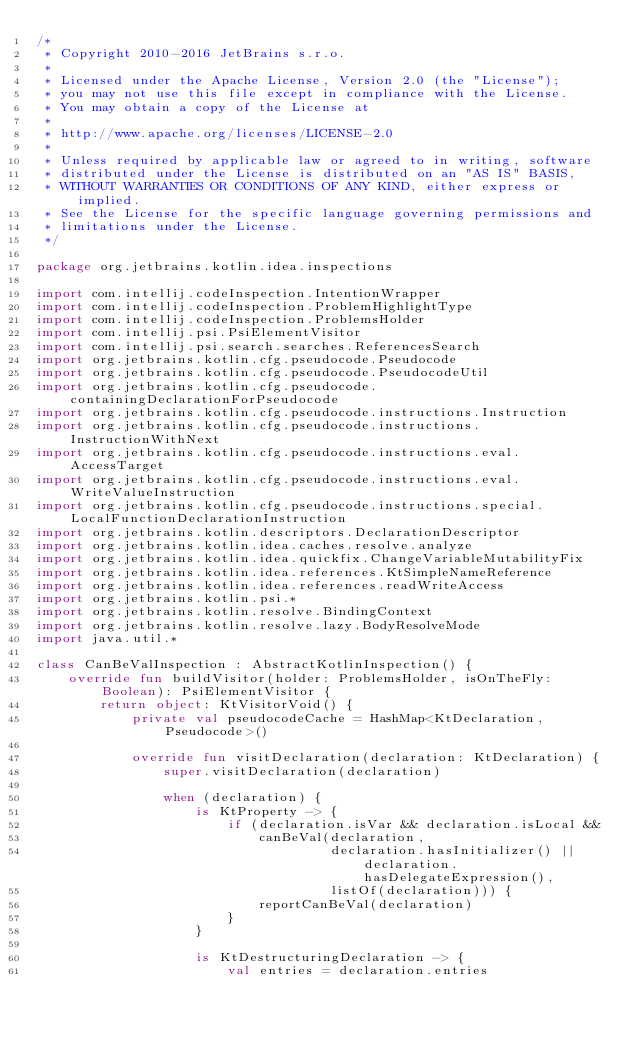Convert code to text. <code><loc_0><loc_0><loc_500><loc_500><_Kotlin_>/*
 * Copyright 2010-2016 JetBrains s.r.o.
 *
 * Licensed under the Apache License, Version 2.0 (the "License");
 * you may not use this file except in compliance with the License.
 * You may obtain a copy of the License at
 *
 * http://www.apache.org/licenses/LICENSE-2.0
 *
 * Unless required by applicable law or agreed to in writing, software
 * distributed under the License is distributed on an "AS IS" BASIS,
 * WITHOUT WARRANTIES OR CONDITIONS OF ANY KIND, either express or implied.
 * See the License for the specific language governing permissions and
 * limitations under the License.
 */

package org.jetbrains.kotlin.idea.inspections

import com.intellij.codeInspection.IntentionWrapper
import com.intellij.codeInspection.ProblemHighlightType
import com.intellij.codeInspection.ProblemsHolder
import com.intellij.psi.PsiElementVisitor
import com.intellij.psi.search.searches.ReferencesSearch
import org.jetbrains.kotlin.cfg.pseudocode.Pseudocode
import org.jetbrains.kotlin.cfg.pseudocode.PseudocodeUtil
import org.jetbrains.kotlin.cfg.pseudocode.containingDeclarationForPseudocode
import org.jetbrains.kotlin.cfg.pseudocode.instructions.Instruction
import org.jetbrains.kotlin.cfg.pseudocode.instructions.InstructionWithNext
import org.jetbrains.kotlin.cfg.pseudocode.instructions.eval.AccessTarget
import org.jetbrains.kotlin.cfg.pseudocode.instructions.eval.WriteValueInstruction
import org.jetbrains.kotlin.cfg.pseudocode.instructions.special.LocalFunctionDeclarationInstruction
import org.jetbrains.kotlin.descriptors.DeclarationDescriptor
import org.jetbrains.kotlin.idea.caches.resolve.analyze
import org.jetbrains.kotlin.idea.quickfix.ChangeVariableMutabilityFix
import org.jetbrains.kotlin.idea.references.KtSimpleNameReference
import org.jetbrains.kotlin.idea.references.readWriteAccess
import org.jetbrains.kotlin.psi.*
import org.jetbrains.kotlin.resolve.BindingContext
import org.jetbrains.kotlin.resolve.lazy.BodyResolveMode
import java.util.*

class CanBeValInspection : AbstractKotlinInspection() {
    override fun buildVisitor(holder: ProblemsHolder, isOnTheFly: Boolean): PsiElementVisitor {
        return object: KtVisitorVoid() {
            private val pseudocodeCache = HashMap<KtDeclaration, Pseudocode>()

            override fun visitDeclaration(declaration: KtDeclaration) {
                super.visitDeclaration(declaration)

                when (declaration) {
                    is KtProperty -> {
                        if (declaration.isVar && declaration.isLocal &&
                            canBeVal(declaration,
                                     declaration.hasInitializer() || declaration.hasDelegateExpression(),
                                     listOf(declaration))) {
                            reportCanBeVal(declaration)
                        }
                    }

                    is KtDestructuringDeclaration -> {
                        val entries = declaration.entries</code> 